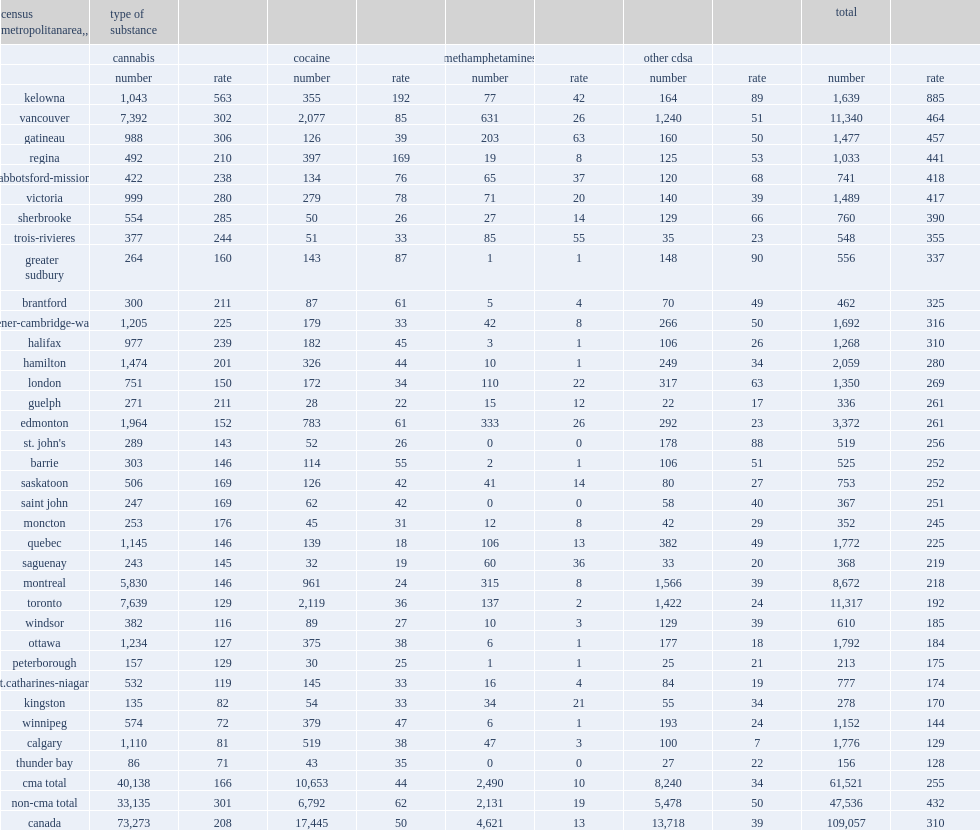Among cmas, what is the rate of kelowna reported the cannabis-related offences? 563.0. Among cmas, which area is the highest rates of cannabis-related offences? Kelowna. Among cmas, what is the rate of kelowna reported the cocaine-related offences? 192.0. Among cmas, which area is the highest rates of cocaine-related offences? Kelowna. Compared with gatineau and kelowna, which area reported higher rates of offences involving methamphetamines in 2013? Gatineau. Compared with trois-rivieres and kelowna, which area reported higher rates of offences involving methamphetamines in 2013? Trois-rivieres. What is the rate of gatineau reported of offences involving methamphetamines in 2013? 63.0. What is the rate of trois-rivieres reported of offences involving methamphetamines in 2013? 55.0. What is the rate of kelowna reported of offences involving methamphetamines in 2013? 42.0. Compared with greater sudbury and kelowna, which area was the only cma to report a higher rate of offences involving other controlled drugs and substances in 2013? Greater sudbury. What is the rate of greater sudbury reported of offences involving other controlled drugs and substances in 2013? 90.0. What is the rate of kelowna reported of offences involving other controlled drugs and substances in 2013? 89.0. 